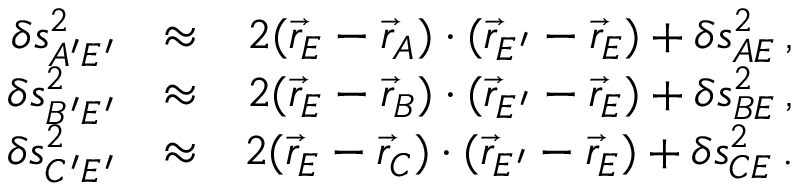Convert formula to latex. <formula><loc_0><loc_0><loc_500><loc_500>\begin{array} { r l r } { \delta s _ { A ^ { \prime } E ^ { \prime } } ^ { 2 } } & { \approx } & { 2 ( \vec { r } _ { E } - \vec { r } _ { A } ) \cdot ( \vec { r } _ { E ^ { \prime } } - \vec { r } _ { E } ) + \delta s _ { A E } ^ { 2 } \, , } \\ { \delta s _ { B ^ { \prime } E ^ { \prime } } ^ { 2 } } & { \approx } & { 2 ( \vec { r } _ { E } - \vec { r } _ { B } ) \cdot ( \vec { r } _ { E ^ { \prime } } - \vec { r } _ { E } ) + \delta s _ { B E } ^ { 2 } \, , } \\ { \delta s _ { C ^ { \prime } E ^ { \prime } } ^ { 2 } } & { \approx } & { 2 ( \vec { r } _ { E } - \vec { r } _ { C } ) \cdot ( \vec { r } _ { E ^ { \prime } } - \vec { r } _ { E } ) + \delta s _ { C E } ^ { 2 } \, . } \end{array}</formula> 